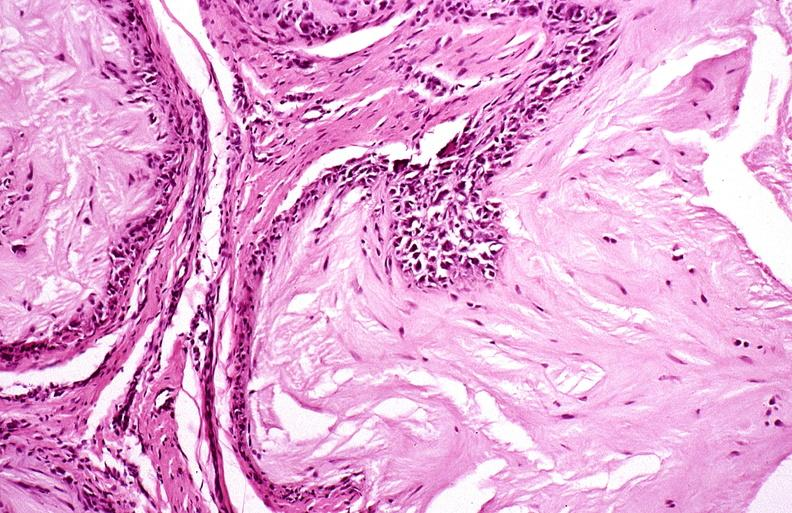s opened abdominal cavity with massive tumor in omentum none apparent in liver nor over peritoneal surfaces gut present?
Answer the question using a single word or phrase. No 